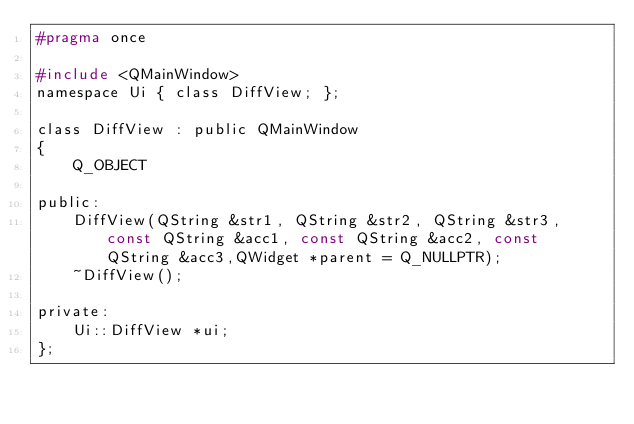<code> <loc_0><loc_0><loc_500><loc_500><_C_>#pragma once

#include <QMainWindow>
namespace Ui { class DiffView; };

class DiffView : public QMainWindow
{
	Q_OBJECT

public:
    DiffView(QString &str1, QString &str2, QString &str3, const QString &acc1, const QString &acc2, const QString &acc3,QWidget *parent = Q_NULLPTR);
	~DiffView();

private:
	Ui::DiffView *ui;
};
</code> 